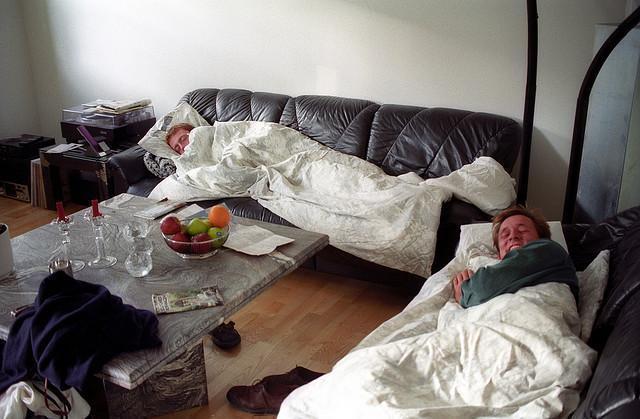How many couches are there?
Give a very brief answer. 2. 